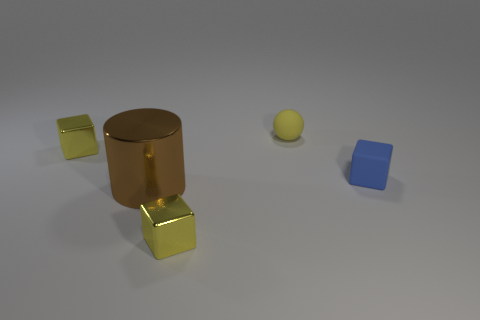How many cubes are the same color as the small ball?
Your answer should be compact. 2. Is there a tiny yellow cube that is left of the big shiny cylinder on the left side of the blue cube?
Your answer should be compact. Yes. How many other things are the same shape as the large object?
Give a very brief answer. 0. There is a tiny blue rubber thing that is on the right side of the big brown cylinder; does it have the same shape as the small shiny thing in front of the big brown cylinder?
Offer a very short reply. Yes. There is a tiny yellow cube behind the cube in front of the brown object; what number of things are right of it?
Ensure brevity in your answer.  4. The large metallic object has what color?
Offer a very short reply. Brown. What number of other objects are the same size as the yellow matte ball?
Your answer should be compact. 3. The small yellow block on the right side of the yellow metal block that is left of the large brown cylinder to the left of the blue object is made of what material?
Provide a succinct answer. Metal. Is there any other thing that is the same color as the matte sphere?
Your answer should be compact. Yes. Does the block that is in front of the large cylinder have the same color as the small metal thing that is behind the brown shiny cylinder?
Offer a very short reply. Yes. 